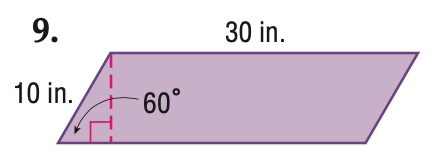Answer the mathemtical geometry problem and directly provide the correct option letter.
Question: Find the area of the parallelogram. Round to the nearest tenth if necessary.
Choices: A: 150 B: 259.9 C: 300 D: 519.6 B 